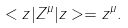Convert formula to latex. <formula><loc_0><loc_0><loc_500><loc_500>< z | Z ^ { \mu } | z > = z ^ { \mu } .</formula> 